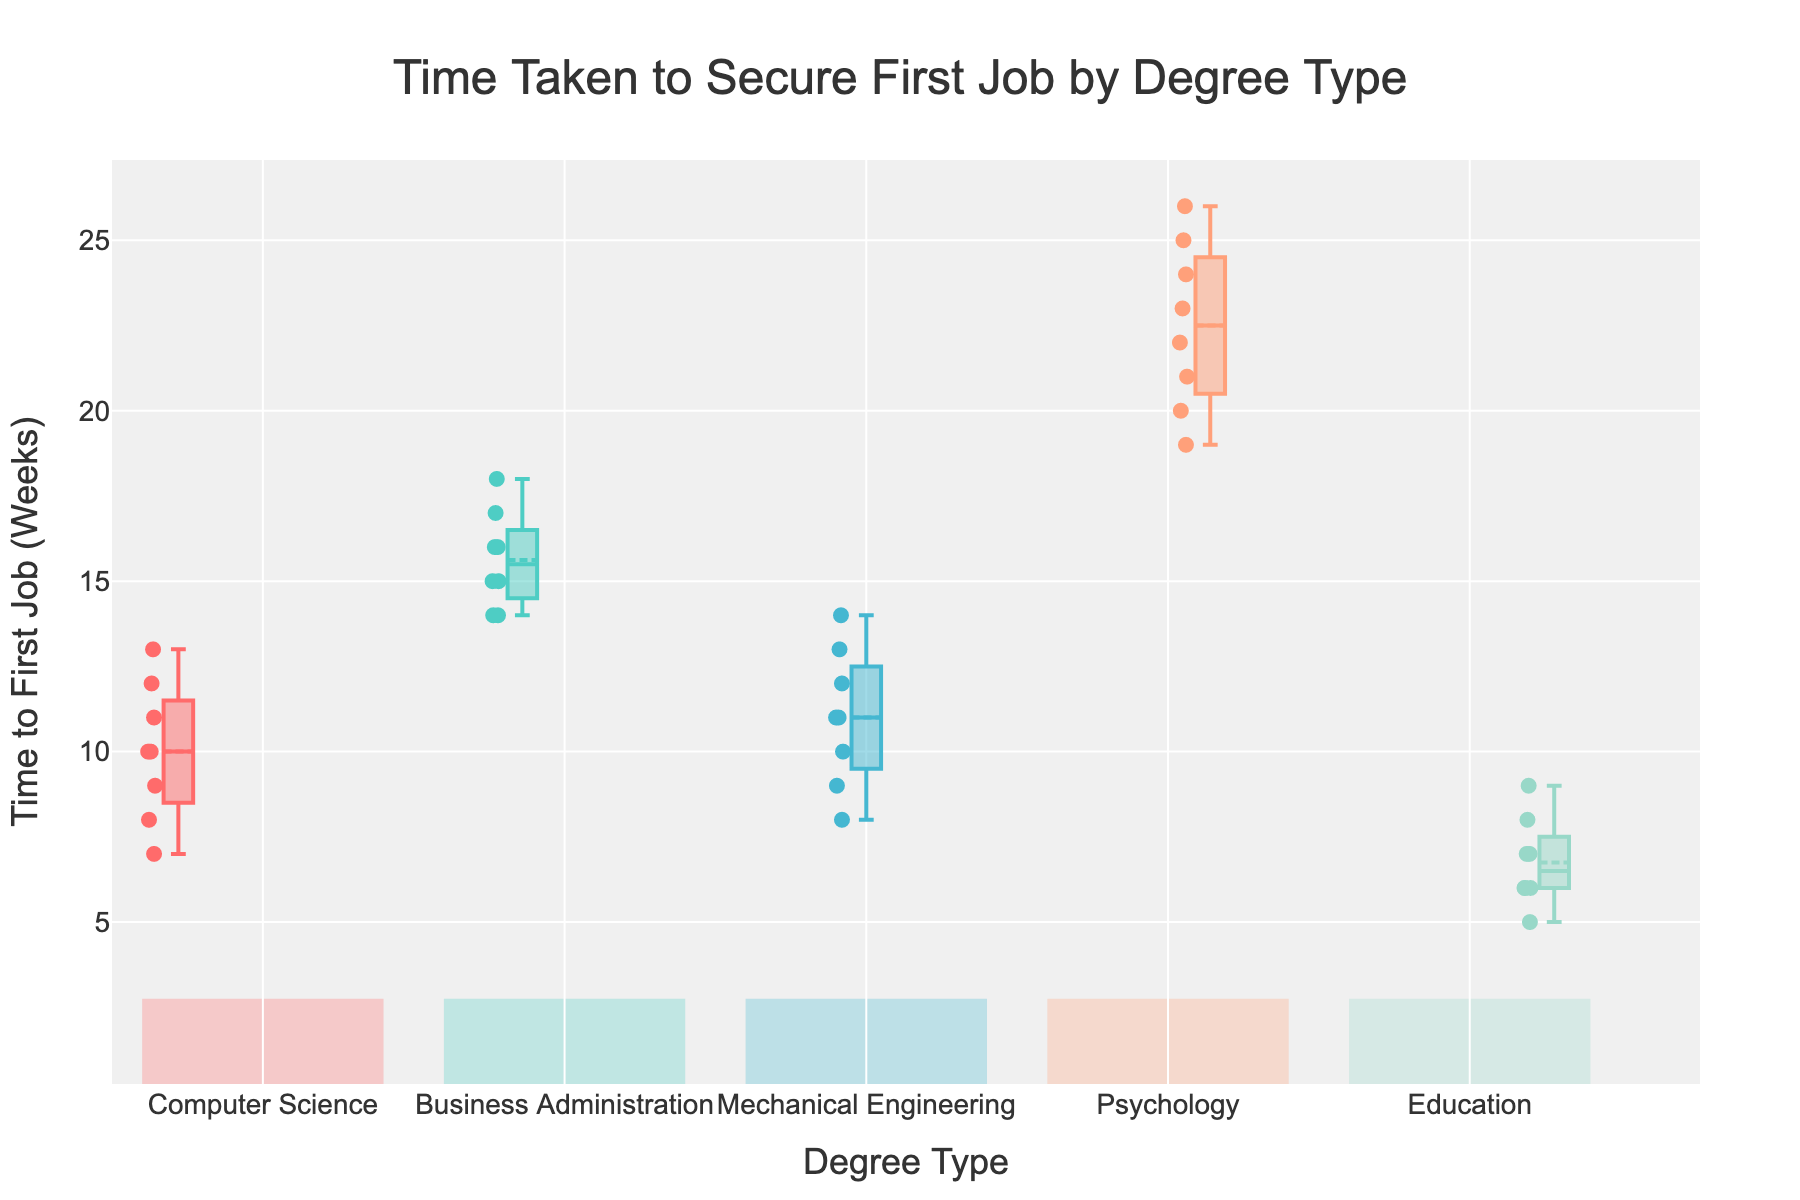What is the title of the figure? The title is typically found at the top of the figure and is clearly labeled.
Answer: Time Taken to Secure First Job by Degree Type How many different degree types are represented in the figure? The number of degree types can be counted from the x-axis labels.
Answer: 5 Which degree type has the lowest median time to secure the first job? The median is represented by the line within the box. Identify the box with the lowest median line.
Answer: Education What is the interquartile range (IQR) for Mechanical Engineering? The IQR is the difference between the third quartile (Q3) and the first quartile (Q1). On the box plot, locate Q3 and Q1 for Mechanical Engineering and subtract them.
Answer: 4 weeks Which degree type shows the most variation in time to secure the first job? The degree with the widest range (distance from the smallest to largest value) indicates the most variation. Evaluate the lengths of the boxes and whiskers.
Answer: Psychology Comparing Computer Science and Business Administration, which has a higher median time to secure the first job? Look at the median line within each box for both degree types. The one with a higher median line has the higher median time.
Answer: Business Administration What is the range of times for Business Administration? The range is the difference between the maximum (top whisker) and minimum (bottom whisker) values. Identify these values for Business Administration and subtract them.
Answer: 4 weeks For which degree type is the interquartile range (IQR) smallest, and what is its value? Compare the IQR (Q3 minus Q1) for each degree type by looking at the height of the boxes. The smallest box height represents the smallest IQR.
Answer: Education, 2 weeks On average, which degree type took the longest time to secure the first job? The mean is represented by a dot or symbol within the box plot. Compare the locations of these symbols for each degree type.
Answer: Psychology How does the distribution of times for securing the first job in Computer Science compare to that in Mechanical Engineering? Compare the medians, IQRs, and ranges for both degree types' box plots.
Answer: CS takes less time on average and has a smaller range than ME 